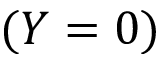Convert formula to latex. <formula><loc_0><loc_0><loc_500><loc_500>( Y = 0 )</formula> 